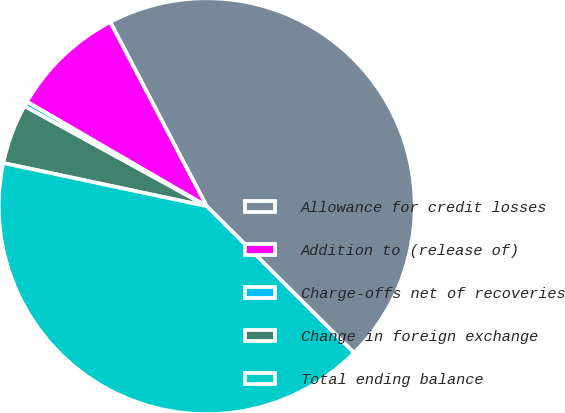Convert chart to OTSL. <chart><loc_0><loc_0><loc_500><loc_500><pie_chart><fcel>Allowance for credit losses<fcel>Addition to (release of)<fcel>Charge-offs net of recoveries<fcel>Change in foreign exchange<fcel>Total ending balance<nl><fcel>45.14%<fcel>8.94%<fcel>0.39%<fcel>4.66%<fcel>40.86%<nl></chart> 